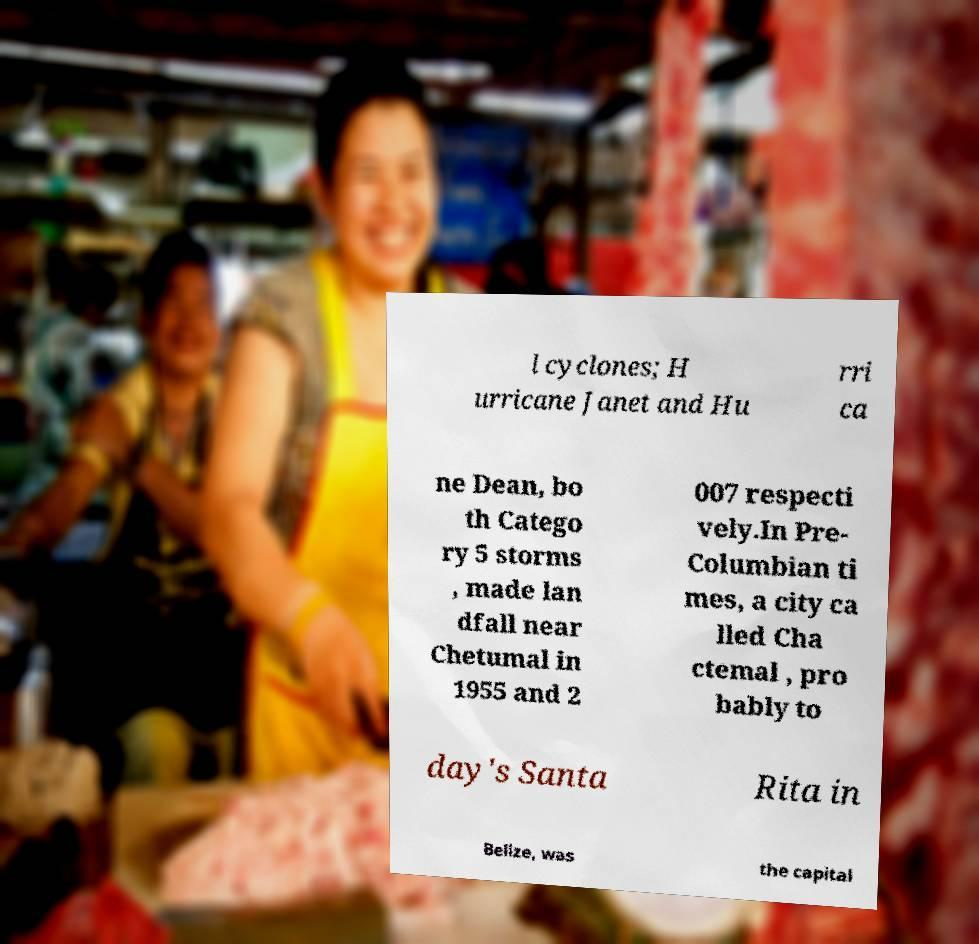Please identify and transcribe the text found in this image. l cyclones; H urricane Janet and Hu rri ca ne Dean, bo th Catego ry 5 storms , made lan dfall near Chetumal in 1955 and 2 007 respecti vely.In Pre- Columbian ti mes, a city ca lled Cha ctemal , pro bably to day's Santa Rita in Belize, was the capital 